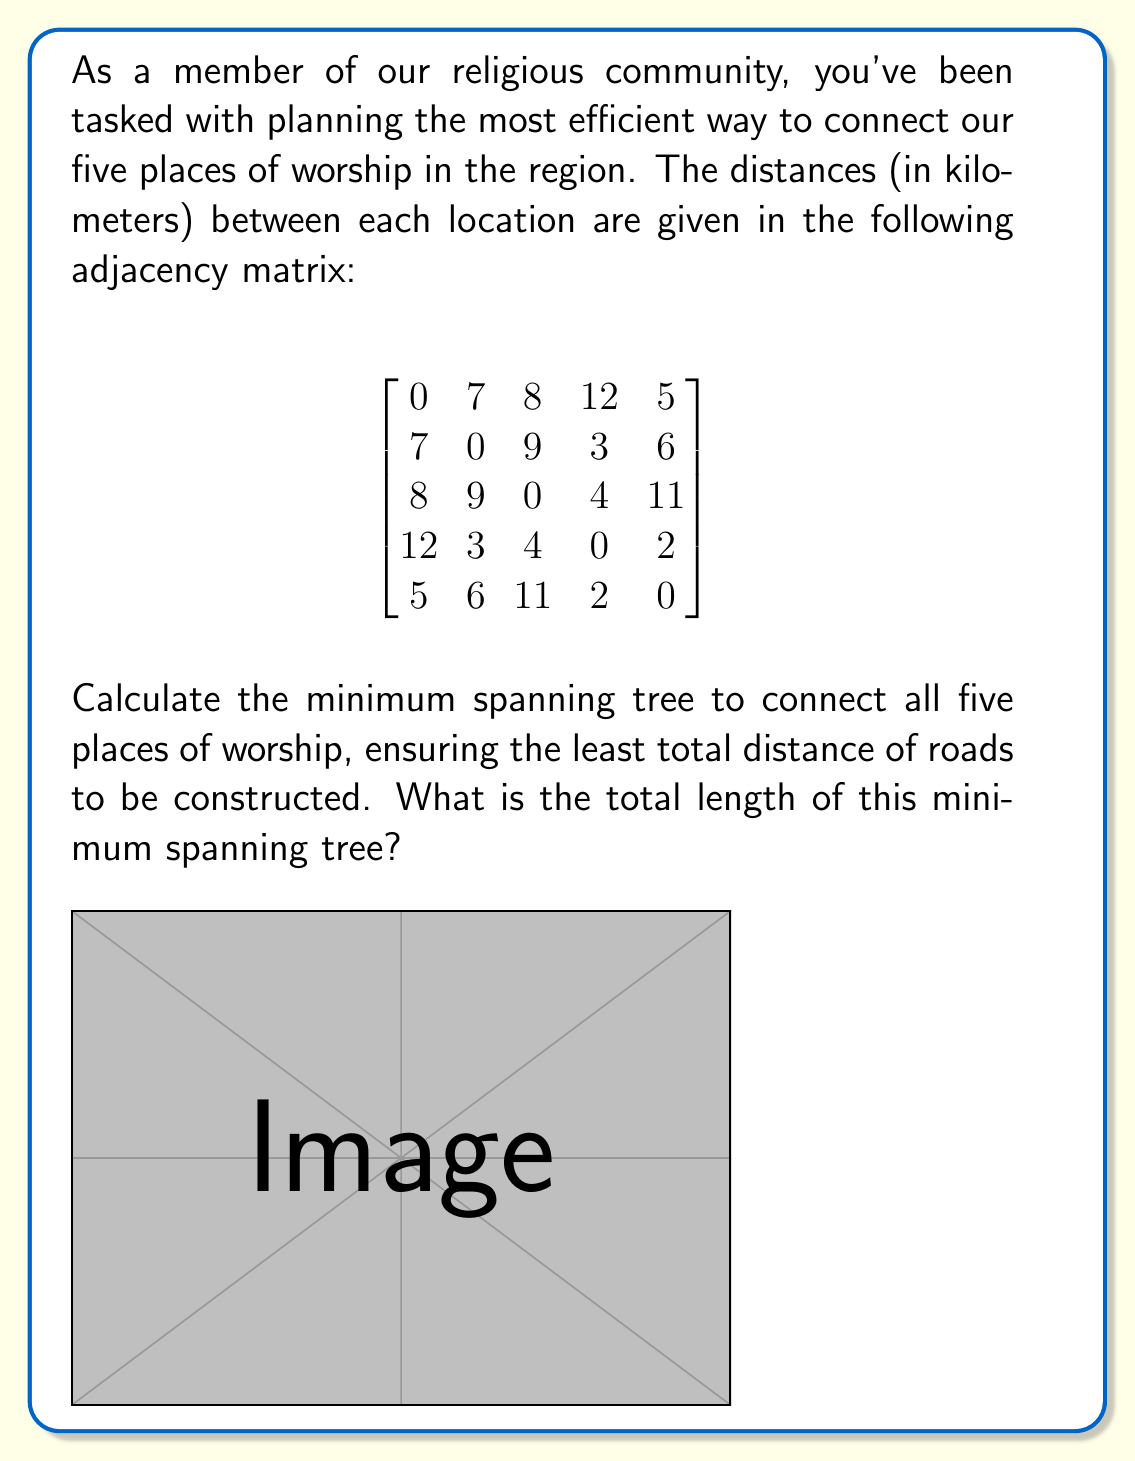Teach me how to tackle this problem. To solve this problem, we'll use Kruskal's algorithm to find the minimum spanning tree (MST). Here are the steps:

1) First, list all edges and their weights in ascending order:
   (D,E): 2
   (B,D): 3
   (C,D): 4
   (A,E): 5
   (B,E): 6
   (A,B): 7
   (A,C): 8
   (B,C): 9
   (C,E): 11
   (A,D): 12

2) Start with an empty graph and add edges in this order, skipping any that would create a cycle:

   - Add (D,E): 2
   - Add (B,D): 3
   - Add (C,D): 4
   - Add (A,E): 5

3) At this point, we have connected all vertices without creating any cycles, so we stop.

4) The MST consists of these edges:
   (D,E): 2
   (B,D): 3
   (C,D): 4
   (A,E): 5

5) Sum the weights of these edges:
   $2 + 3 + 4 + 5 = 14$

Therefore, the total length of the minimum spanning tree is 14 kilometers.

This solution ensures that all five places of worship are connected with the least total distance of roads to be constructed, adhering to the principle of stewardship of resources often emphasized in religious communities.
Answer: The total length of the minimum spanning tree is 14 kilometers. 